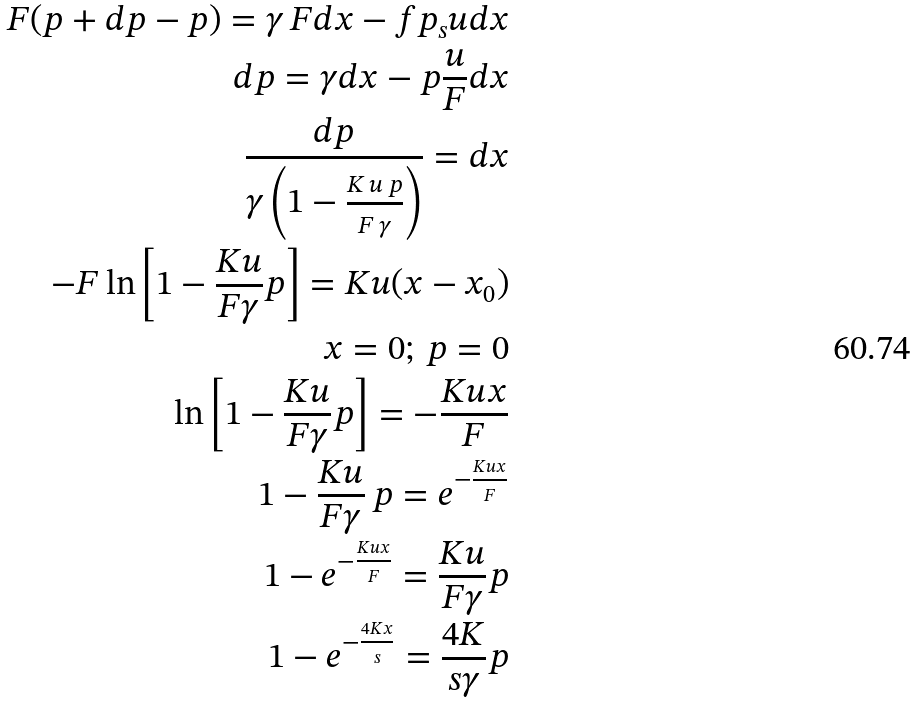Convert formula to latex. <formula><loc_0><loc_0><loc_500><loc_500>F ( p + d p - p ) = \gamma \, F d x - f p _ { s } u d x \\ d p = \gamma d x - p \frac { u } { F } d x \\ \frac { d p } { \gamma \left ( 1 - \frac { K \, u \, p } { F \, \gamma } \right ) } = d x \\ - F \ln \left [ 1 - \frac { K u } { F \gamma } p \right ] = K u ( x - x _ { 0 } ) \\ x = 0 ; \, p = 0 \\ \ln \left [ 1 - \frac { K u } { F \gamma } p \right ] = - \frac { K u x } { F } \\ 1 - \frac { K u } { F \gamma } \, p = e ^ { - \frac { K u x } { F } } \\ 1 - e ^ { - \frac { K u x } { F } } = \frac { K u } { F \gamma } p \\ 1 - e ^ { - \frac { 4 K x } { s } } = \frac { 4 K } { s \gamma } p</formula> 